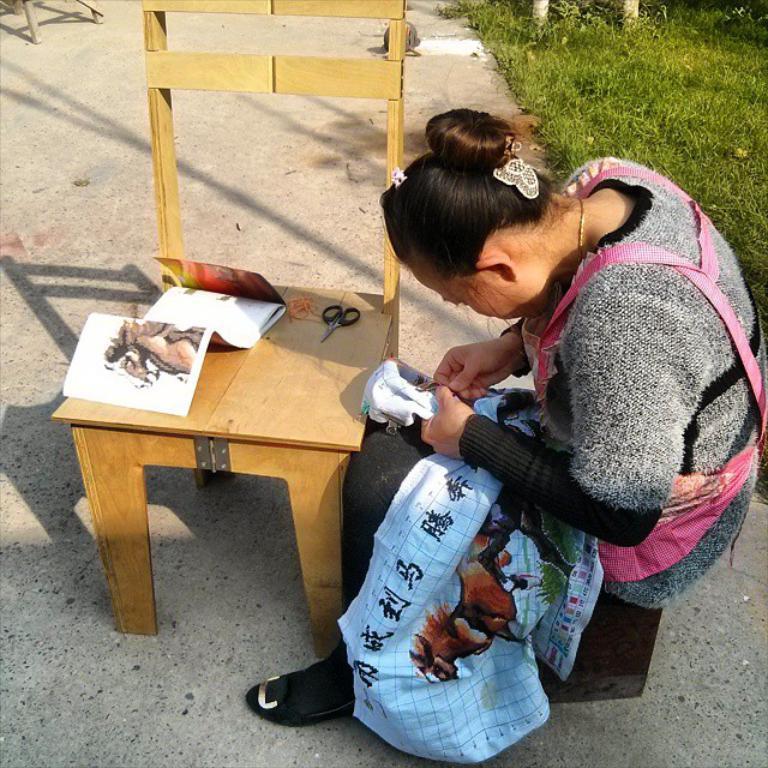Could you give a brief overview of what you see in this image? In the center of the picture there are chair, scissor, book and a woman stitching. On the right there are plants and grass. It is a sunny day. 